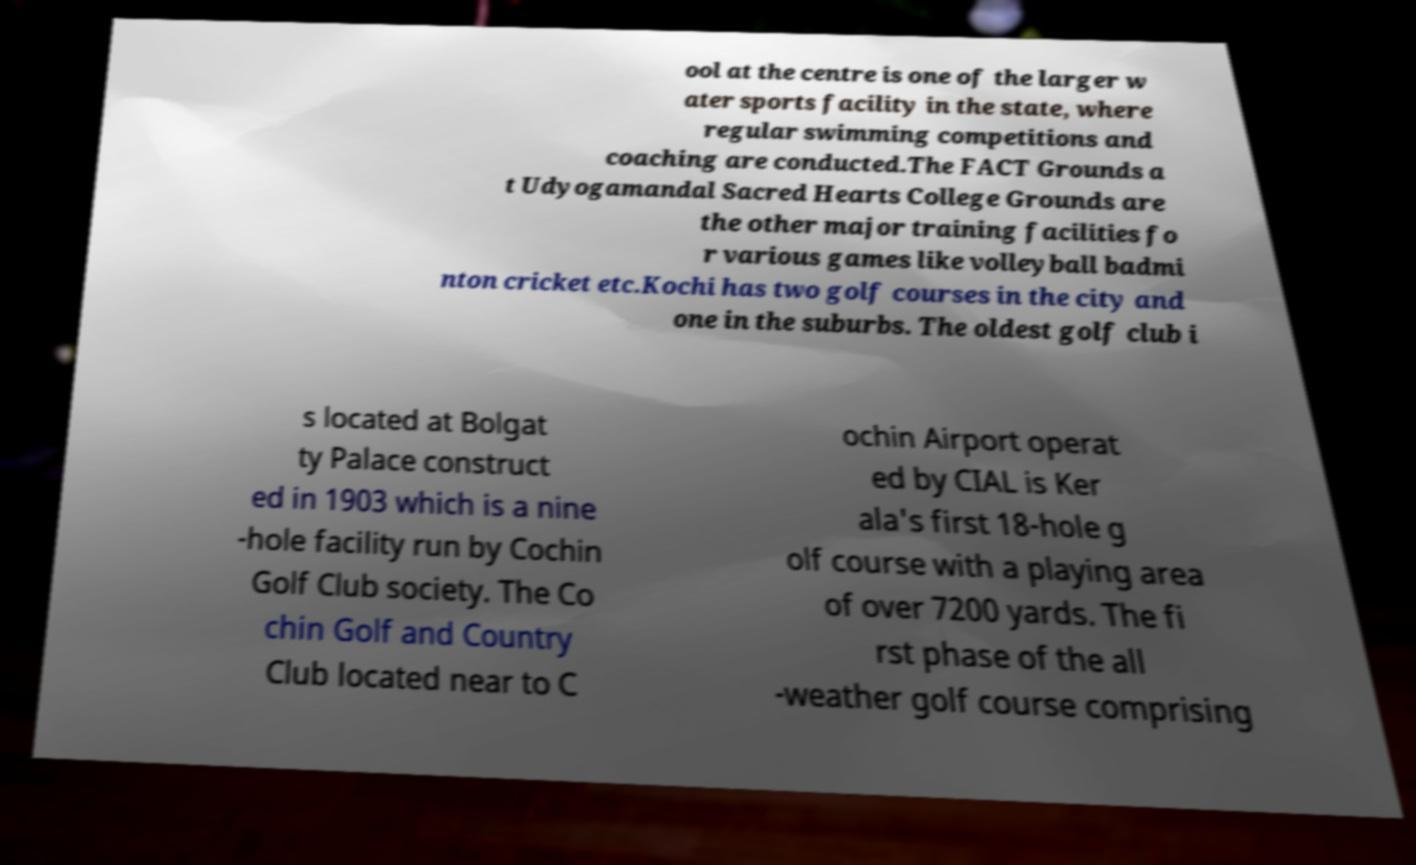Please read and relay the text visible in this image. What does it say? ool at the centre is one of the larger w ater sports facility in the state, where regular swimming competitions and coaching are conducted.The FACT Grounds a t Udyogamandal Sacred Hearts College Grounds are the other major training facilities fo r various games like volleyball badmi nton cricket etc.Kochi has two golf courses in the city and one in the suburbs. The oldest golf club i s located at Bolgat ty Palace construct ed in 1903 which is a nine -hole facility run by Cochin Golf Club society. The Co chin Golf and Country Club located near to C ochin Airport operat ed by CIAL is Ker ala's first 18-hole g olf course with a playing area of over 7200 yards. The fi rst phase of the all -weather golf course comprising 